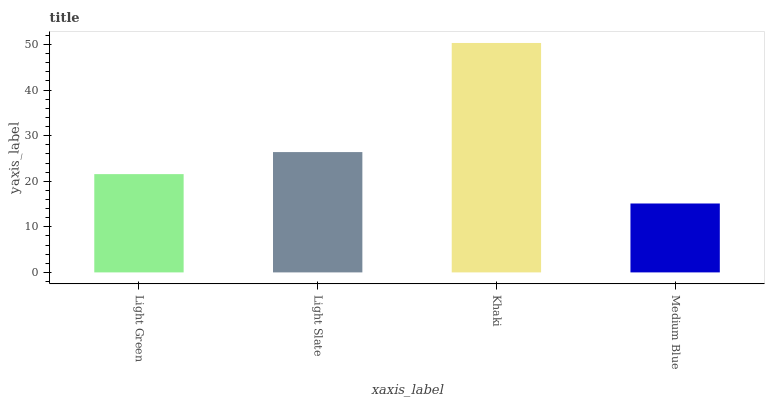Is Light Slate the minimum?
Answer yes or no. No. Is Light Slate the maximum?
Answer yes or no. No. Is Light Slate greater than Light Green?
Answer yes or no. Yes. Is Light Green less than Light Slate?
Answer yes or no. Yes. Is Light Green greater than Light Slate?
Answer yes or no. No. Is Light Slate less than Light Green?
Answer yes or no. No. Is Light Slate the high median?
Answer yes or no. Yes. Is Light Green the low median?
Answer yes or no. Yes. Is Medium Blue the high median?
Answer yes or no. No. Is Light Slate the low median?
Answer yes or no. No. 